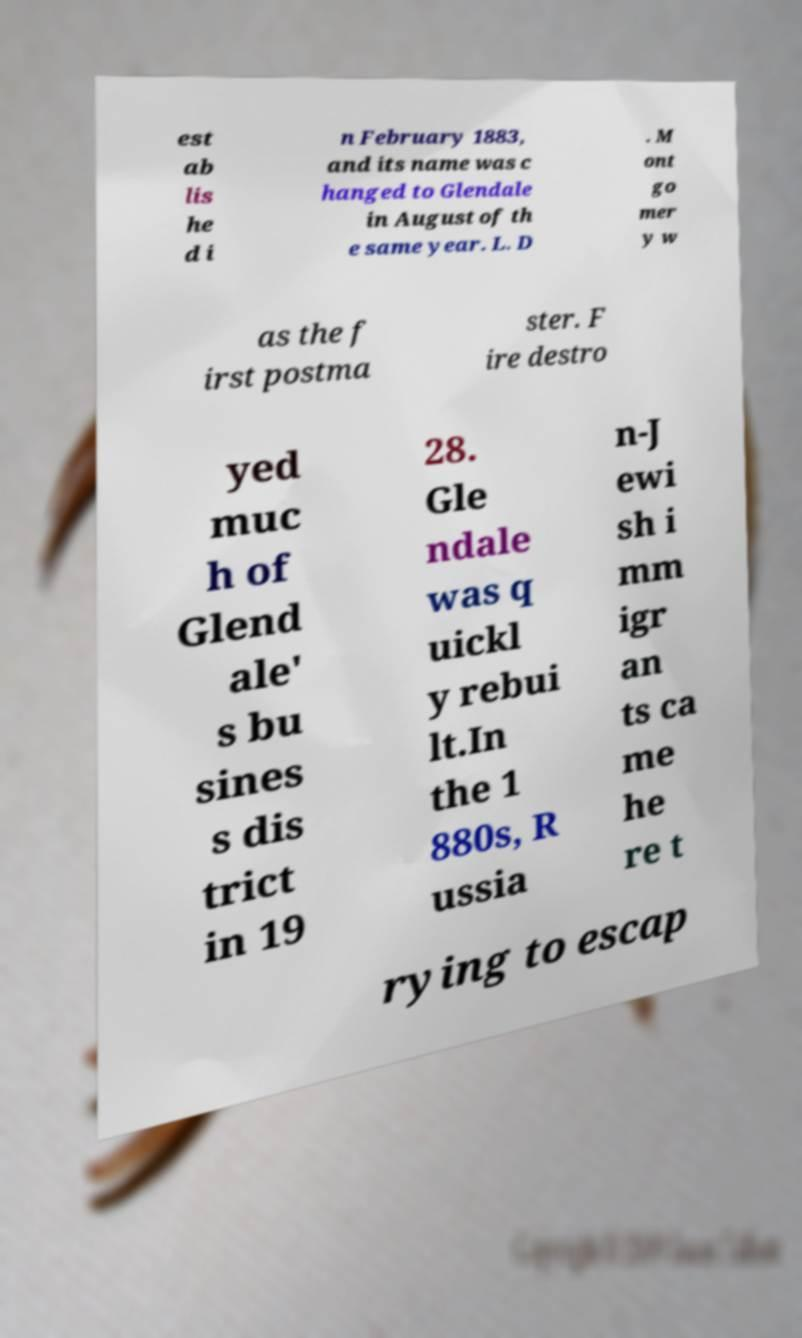What messages or text are displayed in this image? I need them in a readable, typed format. est ab lis he d i n February 1883, and its name was c hanged to Glendale in August of th e same year. L. D . M ont go mer y w as the f irst postma ster. F ire destro yed muc h of Glend ale' s bu sines s dis trict in 19 28. Gle ndale was q uickl y rebui lt.In the 1 880s, R ussia n-J ewi sh i mm igr an ts ca me he re t rying to escap 